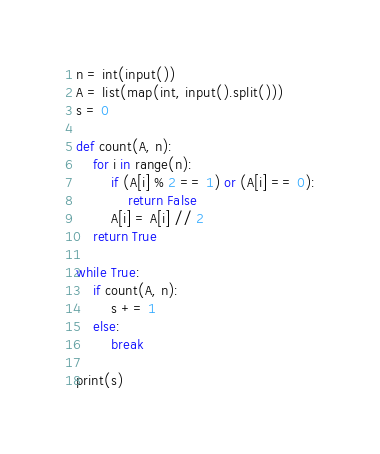Convert code to text. <code><loc_0><loc_0><loc_500><loc_500><_Python_>n = int(input())
A = list(map(int, input().split()))
s = 0

def count(A, n):
    for i in range(n):
        if (A[i] % 2 == 1) or (A[i] == 0):
            return False
        A[i] = A[i] // 2
    return True

while True:
    if count(A, n):
        s += 1
    else:
        break
    
print(s)
</code> 